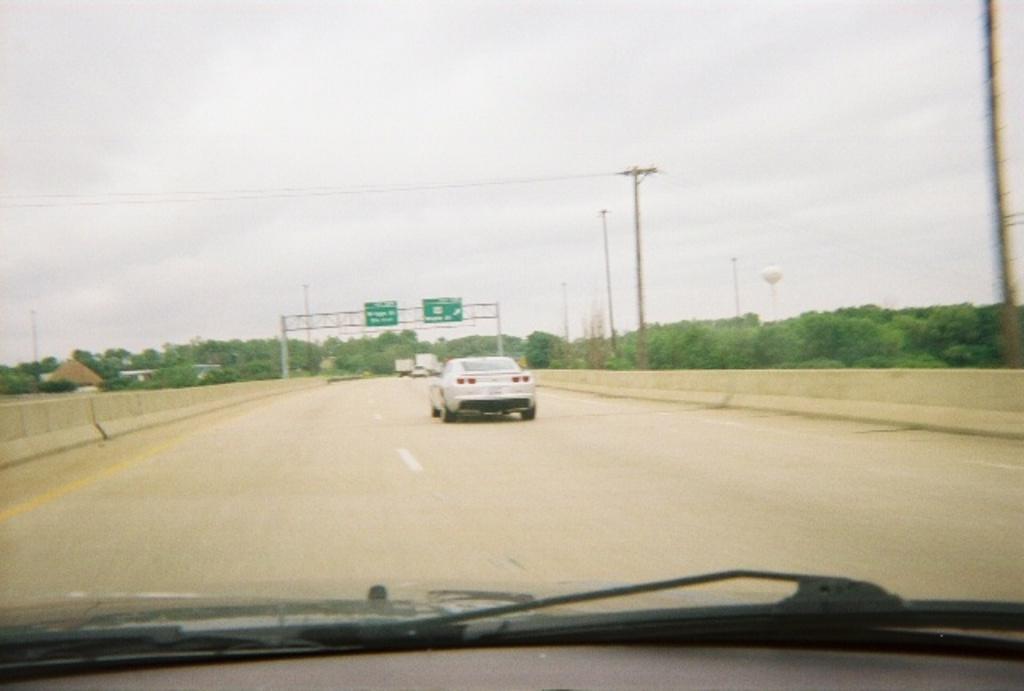Please provide a concise description of this image. In this image I can see a car on the road. In the left and right side of the road I can see many trees and poles. I can see many clouds in the sky. 